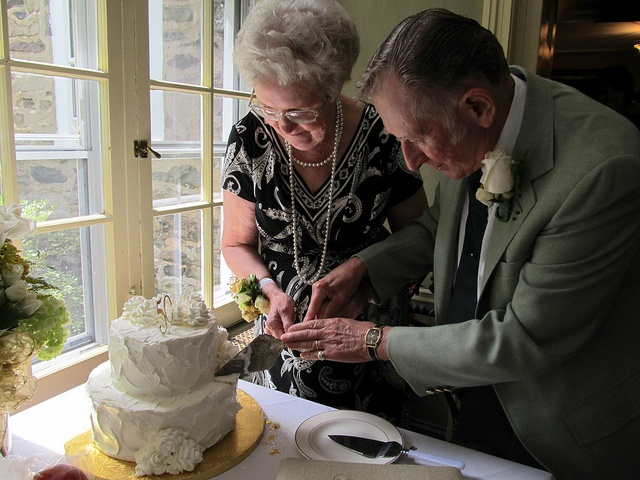Describe the objects in this image and their specific colors. I can see people in khaki, black, gray, and maroon tones, people in khaki, black, gray, maroon, and lightpink tones, dining table in khaki, gray, lightgray, and darkgray tones, cake in khaki, gray, darkgray, and lightgray tones, and potted plant in khaki, olive, black, and darkgray tones in this image. 